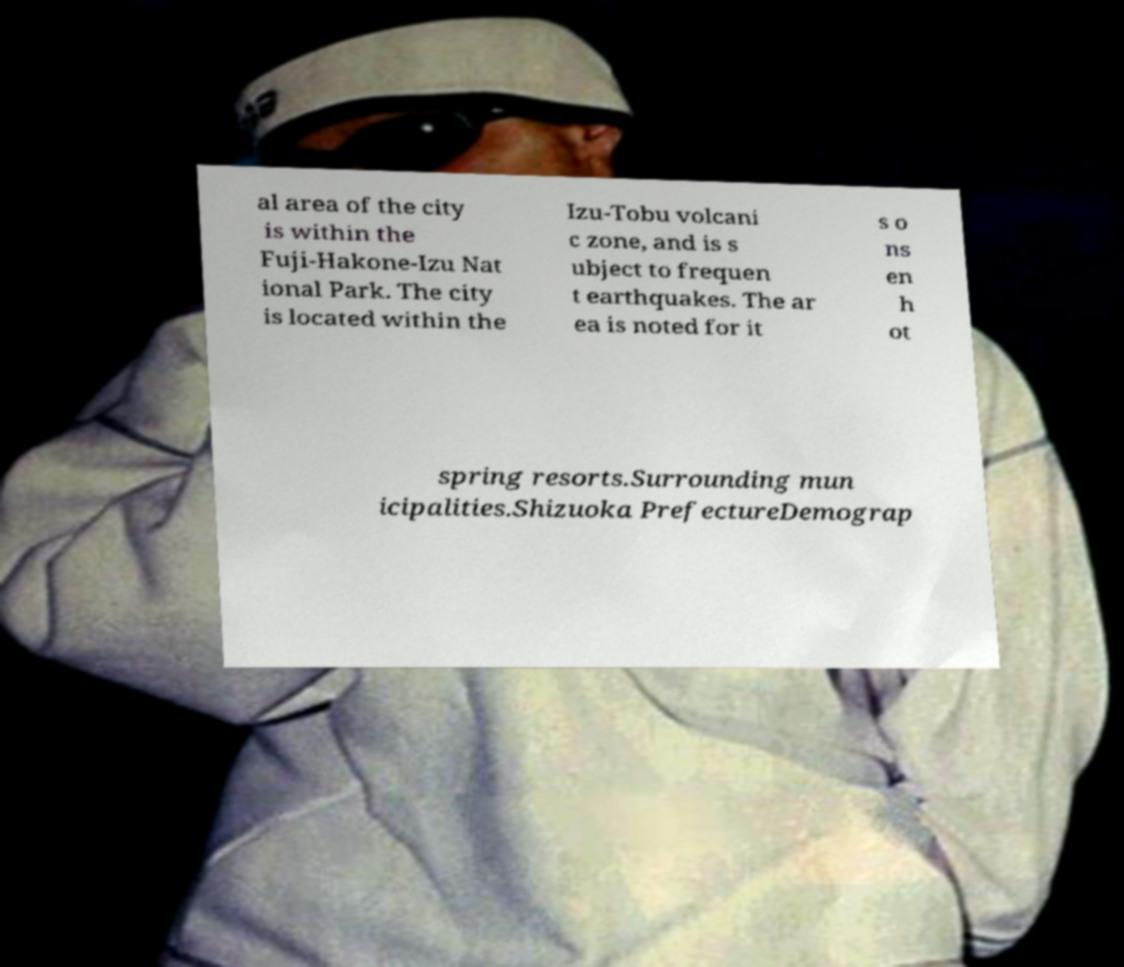For documentation purposes, I need the text within this image transcribed. Could you provide that? al area of the city is within the Fuji-Hakone-Izu Nat ional Park. The city is located within the Izu-Tobu volcani c zone, and is s ubject to frequen t earthquakes. The ar ea is noted for it s o ns en h ot spring resorts.Surrounding mun icipalities.Shizuoka PrefectureDemograp 